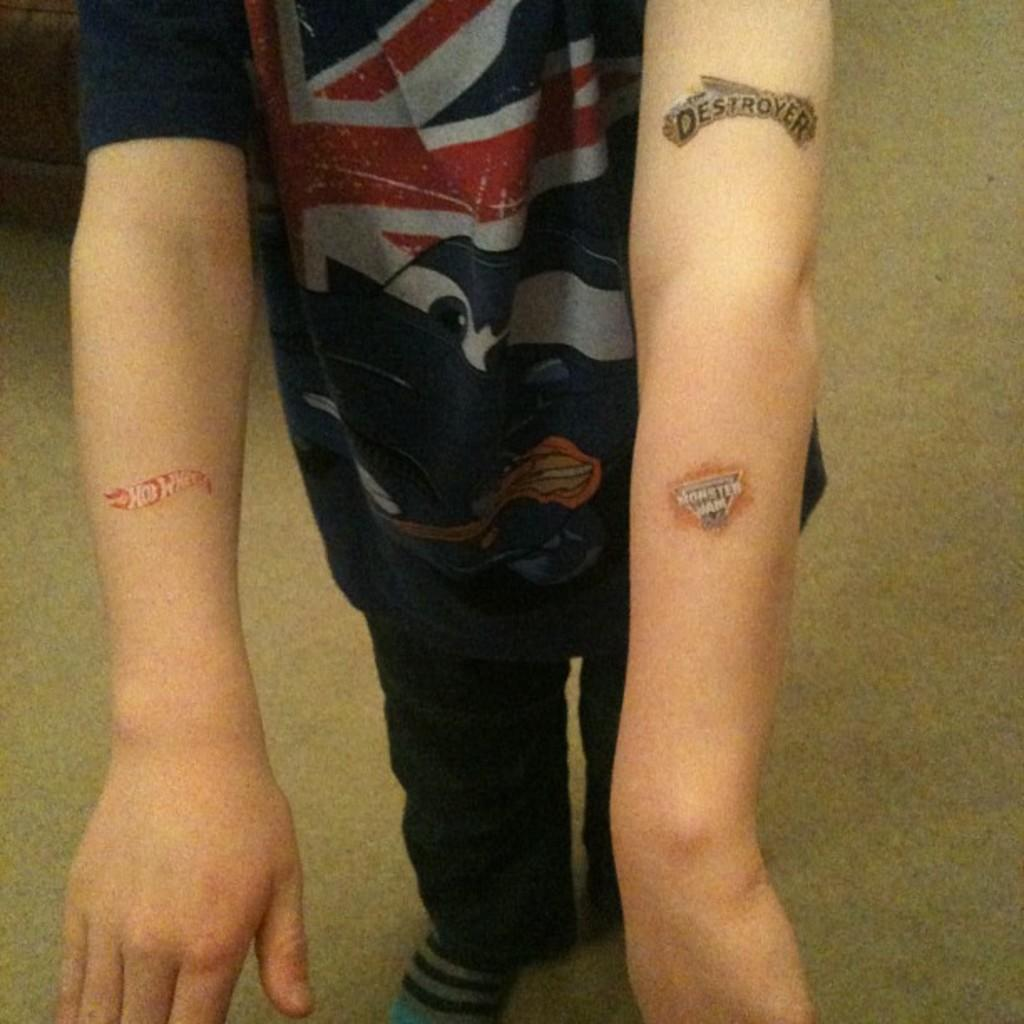<image>
Give a short and clear explanation of the subsequent image. A person shows off some fake tattoos, including one that says destroyer. 